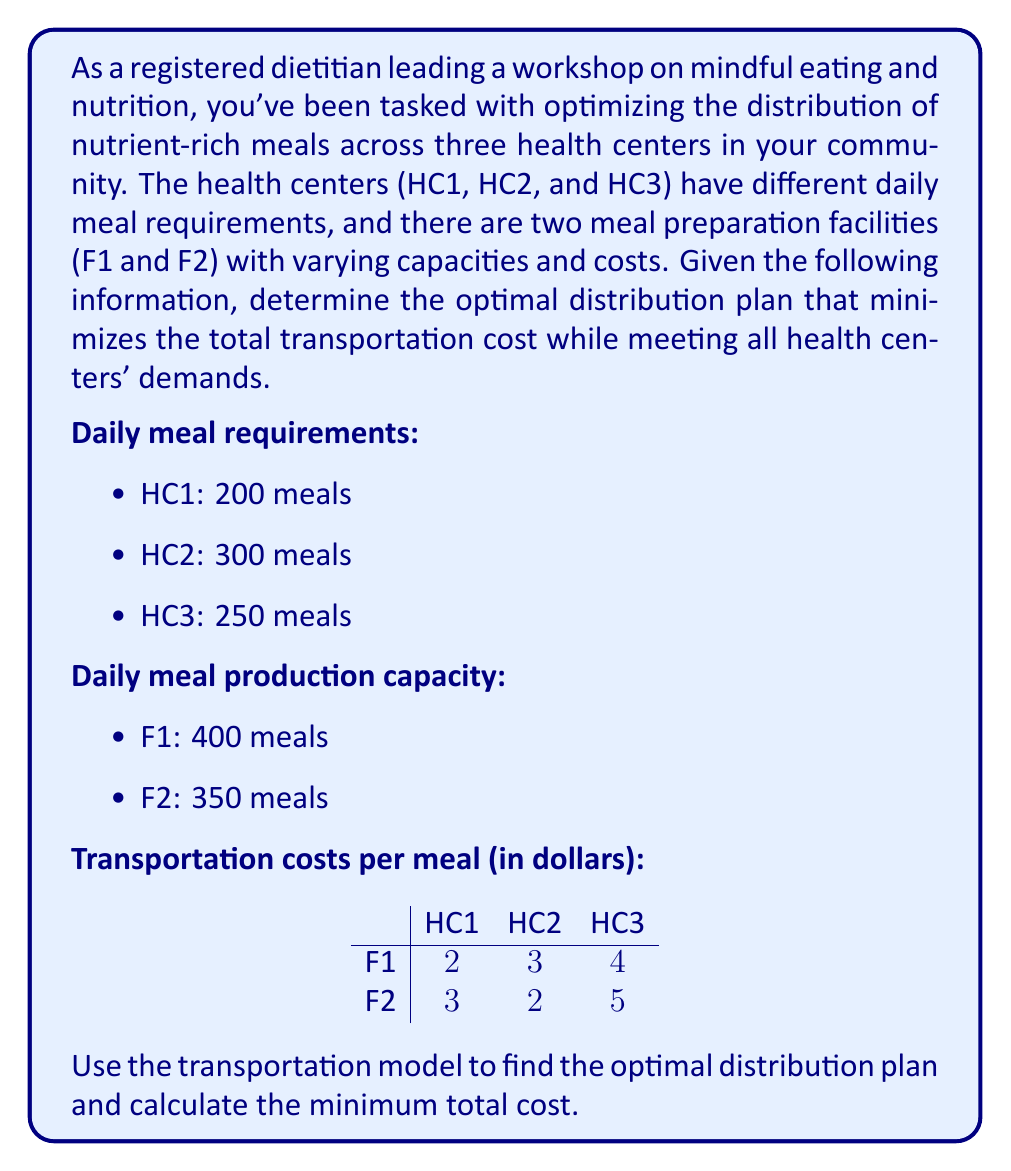Provide a solution to this math problem. To solve this problem, we'll use the transportation model, which is a linear programming method. We'll follow these steps:

1. Set up the initial transportation tableau
2. Check if the problem is balanced
3. Find an initial feasible solution using the Northwest Corner Method
4. Apply the Stepping Stone Method to optimize the solution

Step 1: Set up the initial transportation tableau

$$
\begin{array}{c|ccc|c}
 & \text{HC1} & \text{HC2} & \text{HC3} & \text{Supply} \\
\hline
\text{F1} & 2 & 3 & 4 & 400 \\
\text{F2} & 3 & 2 & 5 & 350 \\
\hline
\text{Demand} & 200 & 300 & 250 & 750
\end{array}
$$

Step 2: Check if the problem is balanced

Total supply = 400 + 350 = 750
Total demand = 200 + 300 + 250 = 750

The problem is balanced, so we can proceed.

Step 3: Find an initial feasible solution using the Northwest Corner Method

$$
\begin{array}{c|ccc|c}
 & \text{HC1} & \text{HC2} & \text{HC3} & \text{Supply} \\
\hline
\text{F1} & 200 & 200 & 0 & 400 \\
\text{F2} & 0 & 100 & 250 & 350 \\
\hline
\text{Demand} & 200 & 300 & 250 & 750
\end{array}
$$

Initial cost = (200 × 2) + (200 × 3) + (100 × 2) + (250 × 5) = 2350

Step 4: Apply the Stepping Stone Method to optimize the solution

We'll calculate the opportunity cost for each empty cell:

For F1 to HC3: +4 -3 +2 -5 = -2
For F2 to HC1: +3 -2 +3 -2 = +2

The negative opportunity cost for F1 to HC3 indicates that we can improve the solution by shifting units to this route.

We can shift 200 units from F1 to HC3:

$$
\begin{array}{c|ccc|c}
 & \text{HC1} & \text{HC2} & \text{HC3} & \text{Supply} \\
\hline
\text{F1} & 200 & 0 & 200 & 400 \\
\text{F2} & 0 & 300 & 50 & 350 \\
\hline
\text{Demand} & 200 & 300 & 250 & 750
\end{array}
$$

New cost = (200 × 2) + (200 × 4) + (300 × 2) + (50 × 5) = 2050

Recalculating opportunity costs:

For F1 to HC2: +3 -4 +5 -2 = +2
For F2 to HC1: +3 -2 +4 -2 = +3

There are no negative opportunity costs, so this is the optimal solution.
Answer: The optimal distribution plan is:
F1 to HC1: 200 meals
F1 to HC3: 200 meals
F2 to HC2: 300 meals
F2 to HC3: 50 meals

The minimum total cost is $2050. 